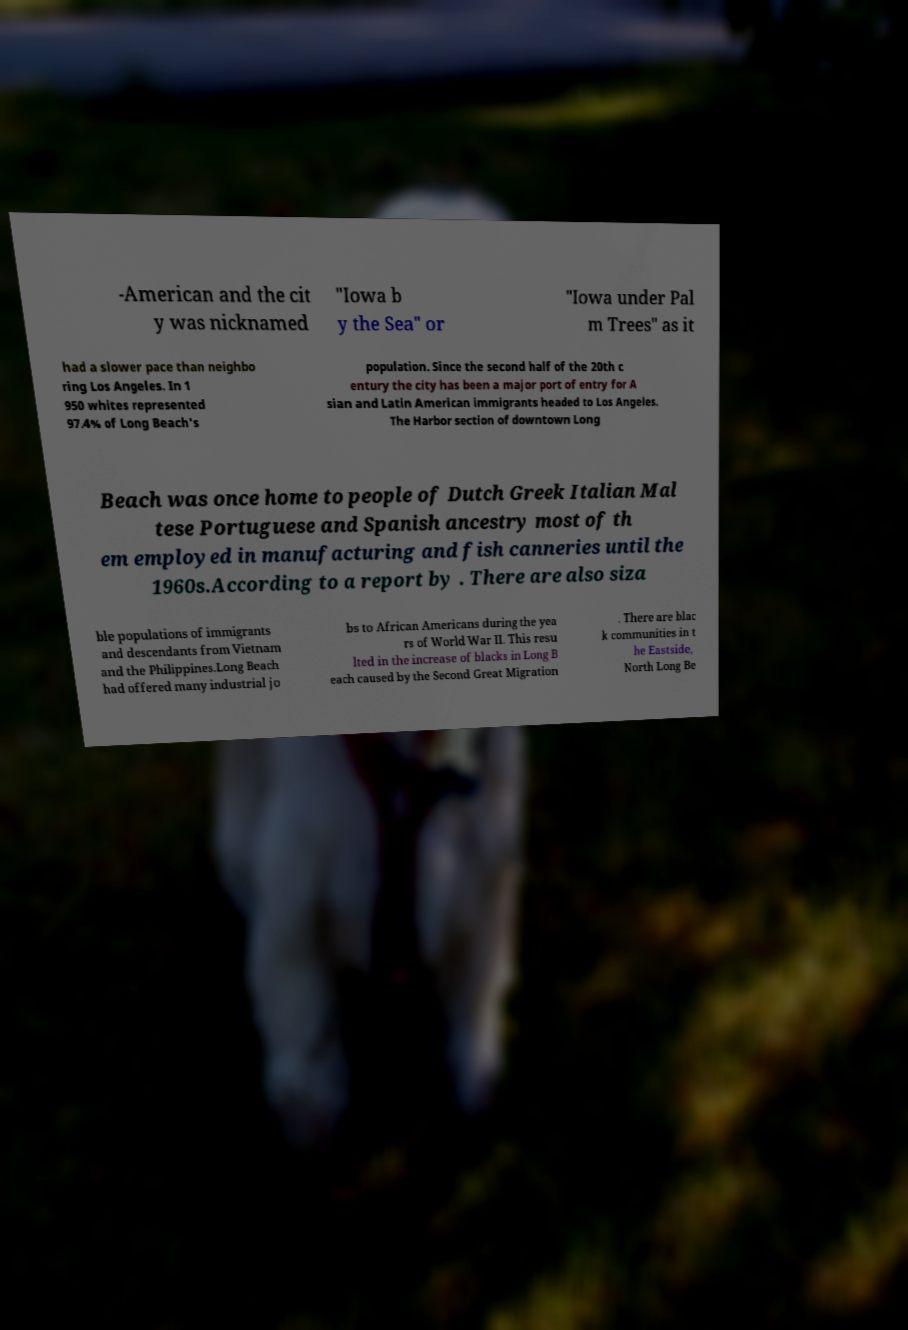Can you accurately transcribe the text from the provided image for me? -American and the cit y was nicknamed "Iowa b y the Sea" or "Iowa under Pal m Trees" as it had a slower pace than neighbo ring Los Angeles. In 1 950 whites represented 97.4% of Long Beach's population. Since the second half of the 20th c entury the city has been a major port of entry for A sian and Latin American immigrants headed to Los Angeles. The Harbor section of downtown Long Beach was once home to people of Dutch Greek Italian Mal tese Portuguese and Spanish ancestry most of th em employed in manufacturing and fish canneries until the 1960s.According to a report by . There are also siza ble populations of immigrants and descendants from Vietnam and the Philippines.Long Beach had offered many industrial jo bs to African Americans during the yea rs of World War II. This resu lted in the increase of blacks in Long B each caused by the Second Great Migration . There are blac k communities in t he Eastside, North Long Be 